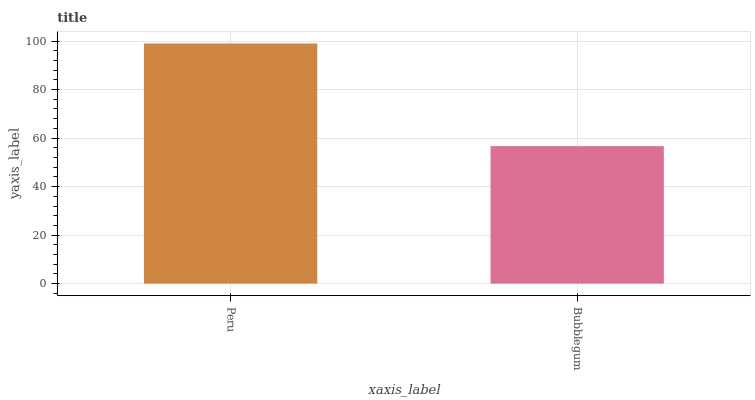Is Bubblegum the minimum?
Answer yes or no. Yes. Is Peru the maximum?
Answer yes or no. Yes. Is Bubblegum the maximum?
Answer yes or no. No. Is Peru greater than Bubblegum?
Answer yes or no. Yes. Is Bubblegum less than Peru?
Answer yes or no. Yes. Is Bubblegum greater than Peru?
Answer yes or no. No. Is Peru less than Bubblegum?
Answer yes or no. No. Is Peru the high median?
Answer yes or no. Yes. Is Bubblegum the low median?
Answer yes or no. Yes. Is Bubblegum the high median?
Answer yes or no. No. Is Peru the low median?
Answer yes or no. No. 